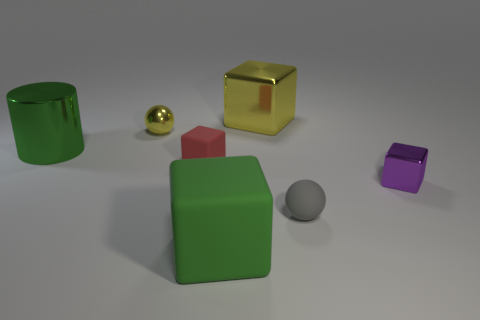There is a big cylinder that is the same color as the large matte object; what material is it?
Your answer should be very brief. Metal. Is there anything else that is the same shape as the big yellow thing?
Provide a succinct answer. Yes. What is the color of the big thing that is in front of the tiny shiny object that is in front of the big shiny object that is in front of the yellow shiny sphere?
Your response must be concise. Green. Is the number of tiny matte objects that are right of the purple metallic thing less than the number of yellow objects that are behind the big metallic block?
Keep it short and to the point. No. Is the gray rubber object the same shape as the tiny purple object?
Make the answer very short. No. How many other shiny spheres have the same size as the yellow sphere?
Make the answer very short. 0. Are there fewer metal cylinders to the right of the small red rubber object than large blue metallic spheres?
Make the answer very short. No. How big is the matte cube to the left of the green object that is in front of the green shiny cylinder?
Provide a succinct answer. Small. What number of objects are big cyan matte spheres or yellow metallic objects?
Ensure brevity in your answer.  2. Are there any other cylinders of the same color as the cylinder?
Provide a short and direct response. No. 